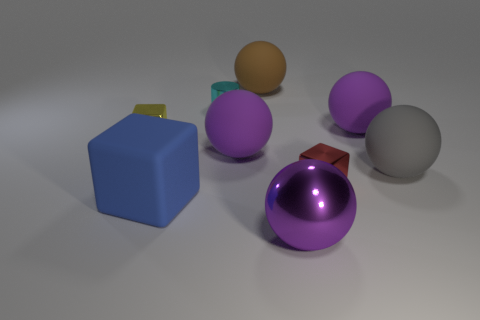Are there any two objects in the image that are identical in every way? No, there are no two objects in the image that are identical in every way. Each object has unique features in terms of shape, size, and color, making each distinct from the others. 